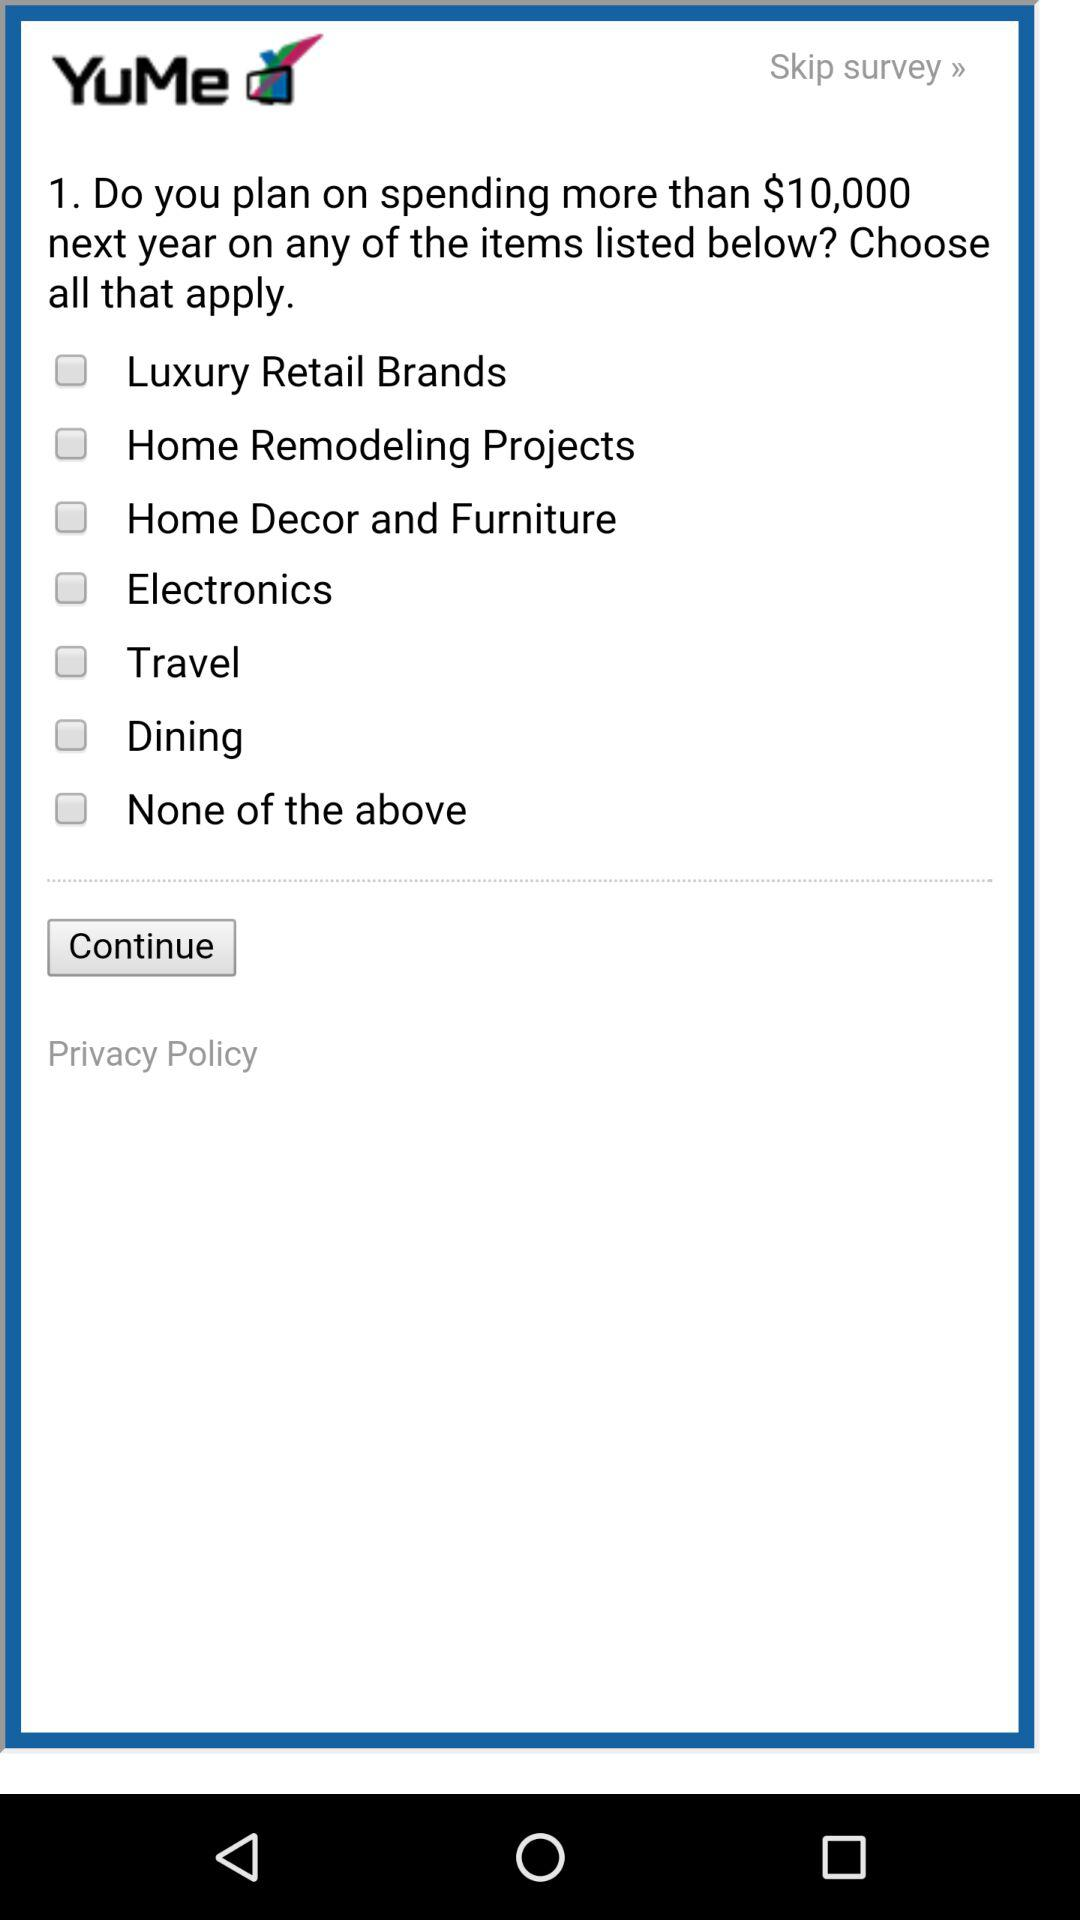What is the name of the application? The name of the application is "YuMe". 